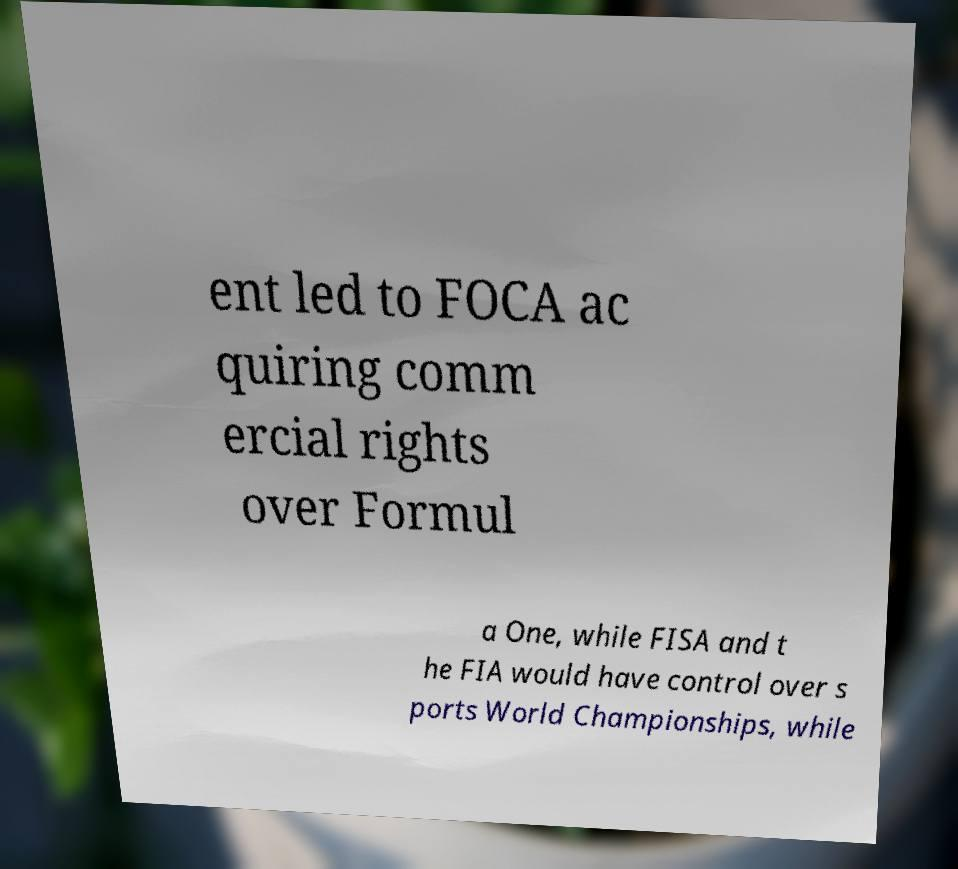Please read and relay the text visible in this image. What does it say? ent led to FOCA ac quiring comm ercial rights over Formul a One, while FISA and t he FIA would have control over s ports World Championships, while 